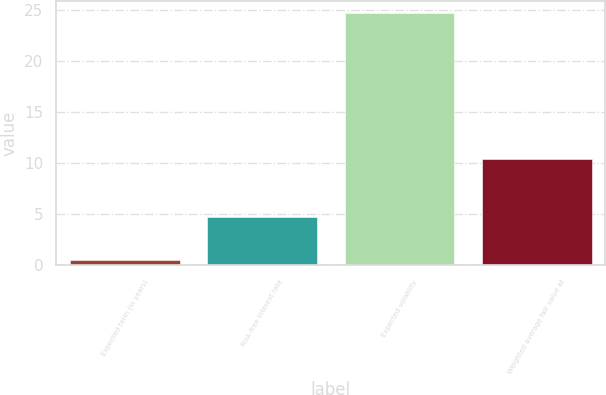Convert chart. <chart><loc_0><loc_0><loc_500><loc_500><bar_chart><fcel>Expected term (in years)<fcel>Risk-free interest rate<fcel>Expected volatility<fcel>Weighted average fair value at<nl><fcel>0.5<fcel>4.7<fcel>24.7<fcel>10.45<nl></chart> 